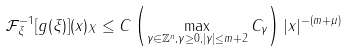Convert formula to latex. <formula><loc_0><loc_0><loc_500><loc_500>\| \mathcal { F } ^ { - 1 } _ { \xi } [ g ( \xi ) ] ( x ) \| _ { X } \leq C \left ( \max _ { \gamma \in \mathbb { Z } ^ { n } , \gamma \geq 0 , | \gamma | \leq m + 2 } C _ { \gamma } \right ) | x | ^ { - ( m + \mu ) }</formula> 